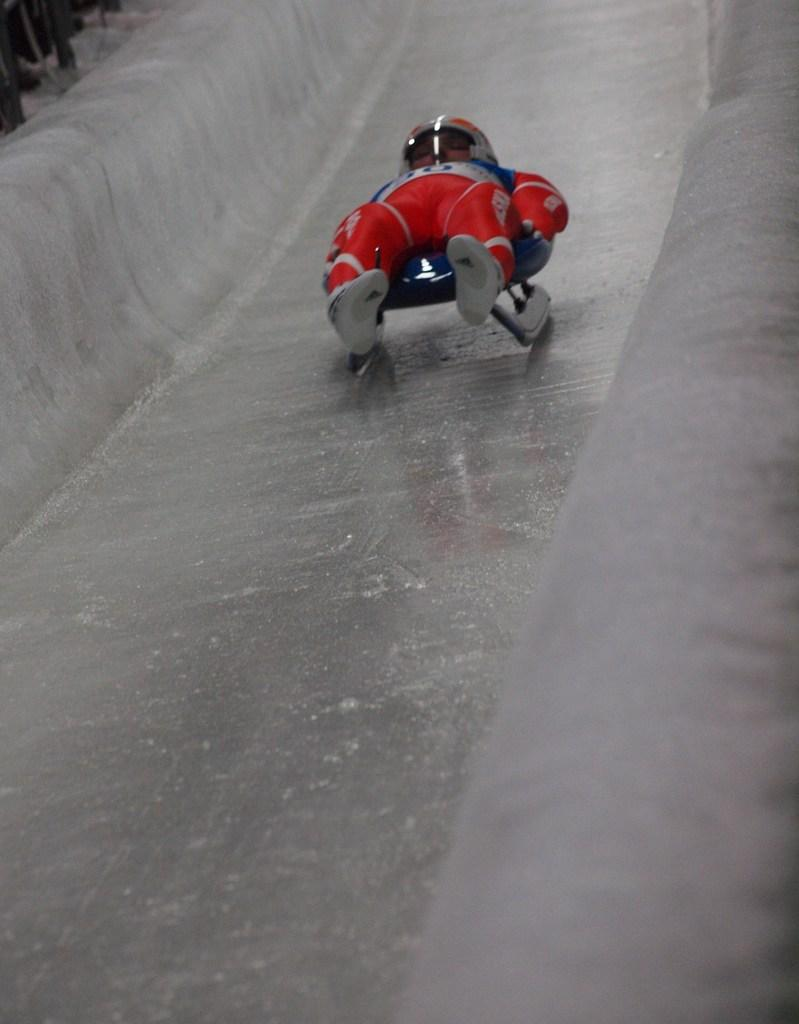Who or what is the main subject in the image? There is a person in the image. What is the person wearing? The person is wearing a helmet. What activity is the person engaged in? The person is riding a luge. What can be seen in the background of the image? There are other objects visible in the background of the image. What type of thread is being used to create the worm's habitat in the image? There is no thread or worm present in the image; it features a person riding a luge. 